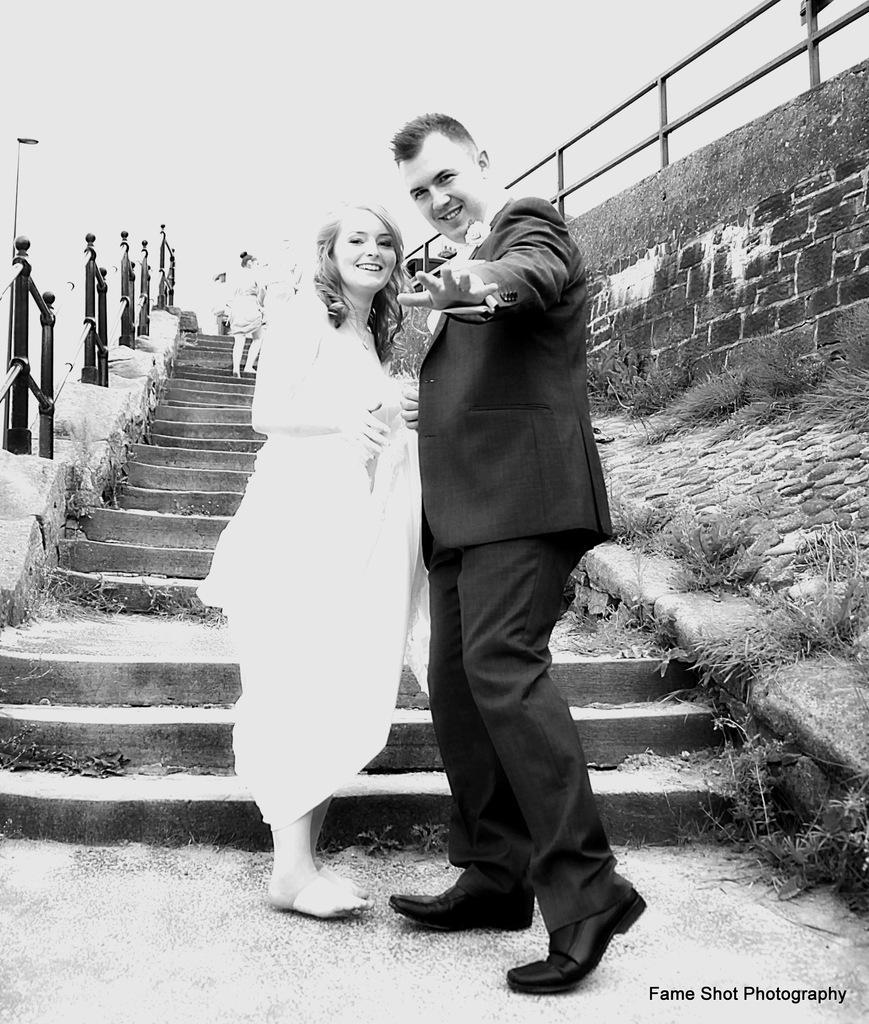In one or two sentences, can you explain what this image depicts? In the foreground, I can see two persons are standing on the road and I can see a text. In the background, I can see grass, fence, two persons on the steps and I can see the sky. This picture might be taken in a day. 